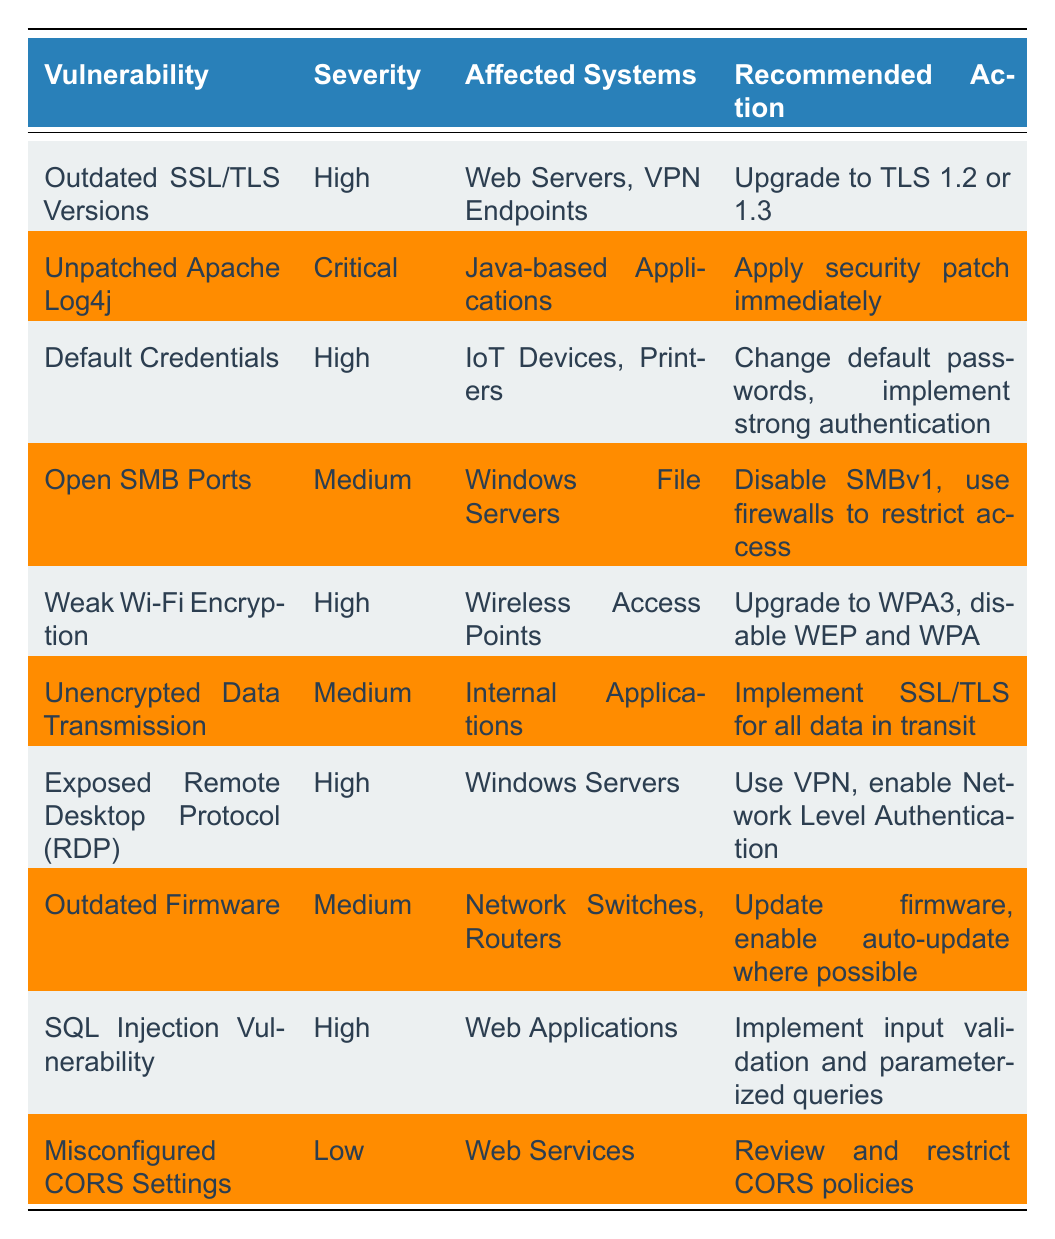What is the severity of "Unpatched Apache Log4j"? The severity is listed directly in the table under the "Severity" column for the "Unpatched Apache Log4j" vulnerability. It is marked as "Critical."
Answer: Critical How many vulnerabilities are labeled as "High" severity? To find the count of "High" severity vulnerabilities, we can review the table and tally the rows where the Severity column states "High." There are five instances of "High" severity.
Answer: 5 Is "Weak Wi-Fi Encryption" considered a "Low" severity vulnerability? By checking the Severity column for "Weak Wi-Fi Encryption," we see that it is marked as "High," not "Low." Therefore, the statement is false.
Answer: No What recommended action is suggested for "Open SMB Ports"? The table provides the recommended action corresponding to "Open SMB Ports," which is to "Disable SMBv1, use firewalls to restrict access."
Answer: Disable SMBv1, use firewalls to restrict access What is the relationship between high severity vulnerabilities and the affected systems? The table shows that the high severity vulnerabilities are "Outdated SSL/TLS Versions," "Default Credentials," "Weak Wi-Fi Encryption," "Exposed Remote Desktop Protocol," and "SQL Injection Vulnerability." The affected systems include Web Servers, IoT Devices, Wireless Access Points, Windows Servers, and Web Applications. This indicates that several critical systems are at risk.
Answer: Several critical systems are at risk What action should be taken regarding default credentials found in IoT devices? The table specifies the action to be taken: "Change default passwords, implement strong authentication." This response is directly referenced in the Recommended Action column for Default Credentials.
Answer: Change default passwords, implement strong authentication If all vulnerabilities were to be prioritized, which one has the highest severity and what action is required? The highest severity listed in the table is for "Unpatched Apache Log4j," categorized as "Critical." The recommended action for this vulnerability is to "Apply security patch immediately." Therefore, this would be the top priority to address.
Answer: Apply security patch immediately What are the affected systems for the "Misconfigured CORS Settings" vulnerability? The affected systems listed in the table for "Misconfigured CORS Settings" are "Web Services." This direct reference is found in the Affected Systems column related to this vulnerability.
Answer: Web Services How does the recommended action for "SQL Injection Vulnerability" differ from that of "Unencrypted Data Transmission"? The recommended action for "SQL Injection Vulnerability" involves implementing "input validation and parameterized queries," while for "Unencrypted Data Transmission," it is to "Implement SSL/TLS for all data in transit." This shows two different security approaches addressing different types of vulnerabilities.
Answer: Two different security approaches 